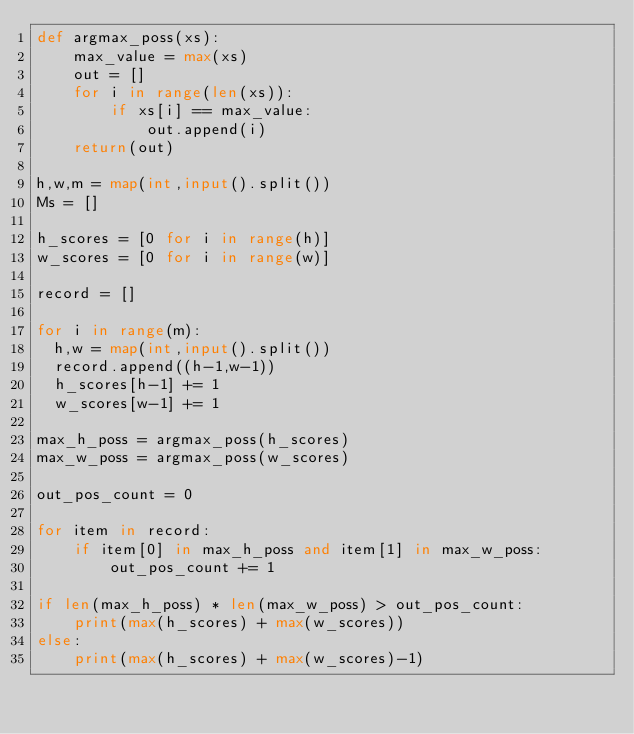<code> <loc_0><loc_0><loc_500><loc_500><_Python_>def argmax_poss(xs):
    max_value = max(xs)
    out = []
    for i in range(len(xs)):
        if xs[i] == max_value:
            out.append(i)
    return(out)

h,w,m = map(int,input().split())
Ms = []

h_scores = [0 for i in range(h)]
w_scores = [0 for i in range(w)]

record = []

for i in range(m):
  h,w = map(int,input().split())
  record.append((h-1,w-1))
  h_scores[h-1] += 1
  w_scores[w-1] += 1

max_h_poss = argmax_poss(h_scores)
max_w_poss = argmax_poss(w_scores)

out_pos_count = 0 

for item in record:
    if item[0] in max_h_poss and item[1] in max_w_poss:
        out_pos_count += 1

if len(max_h_poss) * len(max_w_poss) > out_pos_count:
    print(max(h_scores) + max(w_scores))
else:
    print(max(h_scores) + max(w_scores)-1)

</code> 